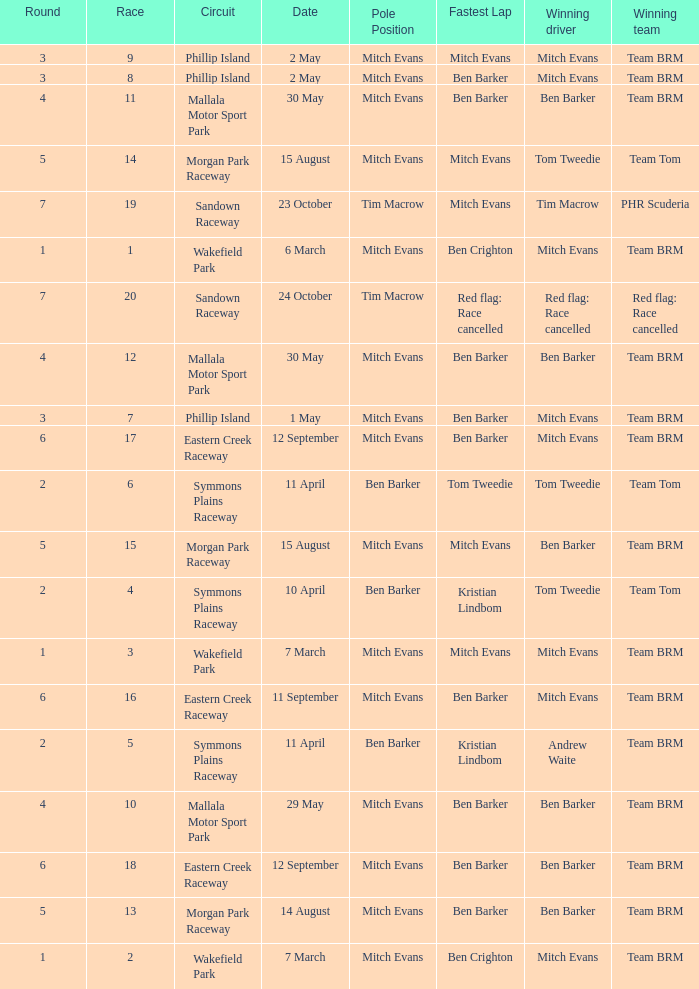What team won Race 17? Team BRM. 